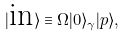<formula> <loc_0><loc_0><loc_500><loc_500>| \text {in} \rangle \equiv \Omega | 0 \rangle _ { \gamma } | p \rangle ,</formula> 